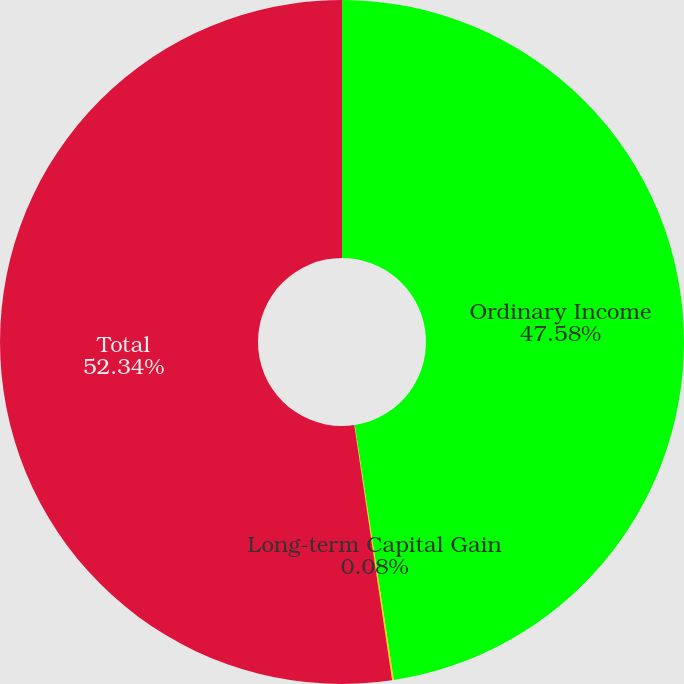<chart> <loc_0><loc_0><loc_500><loc_500><pie_chart><fcel>Ordinary Income<fcel>Long-term Capital Gain<fcel>Total<nl><fcel>47.58%<fcel>0.08%<fcel>52.34%<nl></chart> 